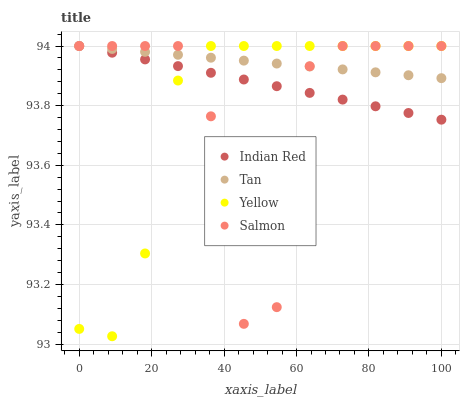Does Yellow have the minimum area under the curve?
Answer yes or no. Yes. Does Tan have the maximum area under the curve?
Answer yes or no. Yes. Does Salmon have the minimum area under the curve?
Answer yes or no. No. Does Salmon have the maximum area under the curve?
Answer yes or no. No. Is Tan the smoothest?
Answer yes or no. Yes. Is Salmon the roughest?
Answer yes or no. Yes. Is Yellow the smoothest?
Answer yes or no. No. Is Yellow the roughest?
Answer yes or no. No. Does Yellow have the lowest value?
Answer yes or no. Yes. Does Salmon have the lowest value?
Answer yes or no. No. Does Indian Red have the highest value?
Answer yes or no. Yes. Does Tan intersect Salmon?
Answer yes or no. Yes. Is Tan less than Salmon?
Answer yes or no. No. Is Tan greater than Salmon?
Answer yes or no. No. 